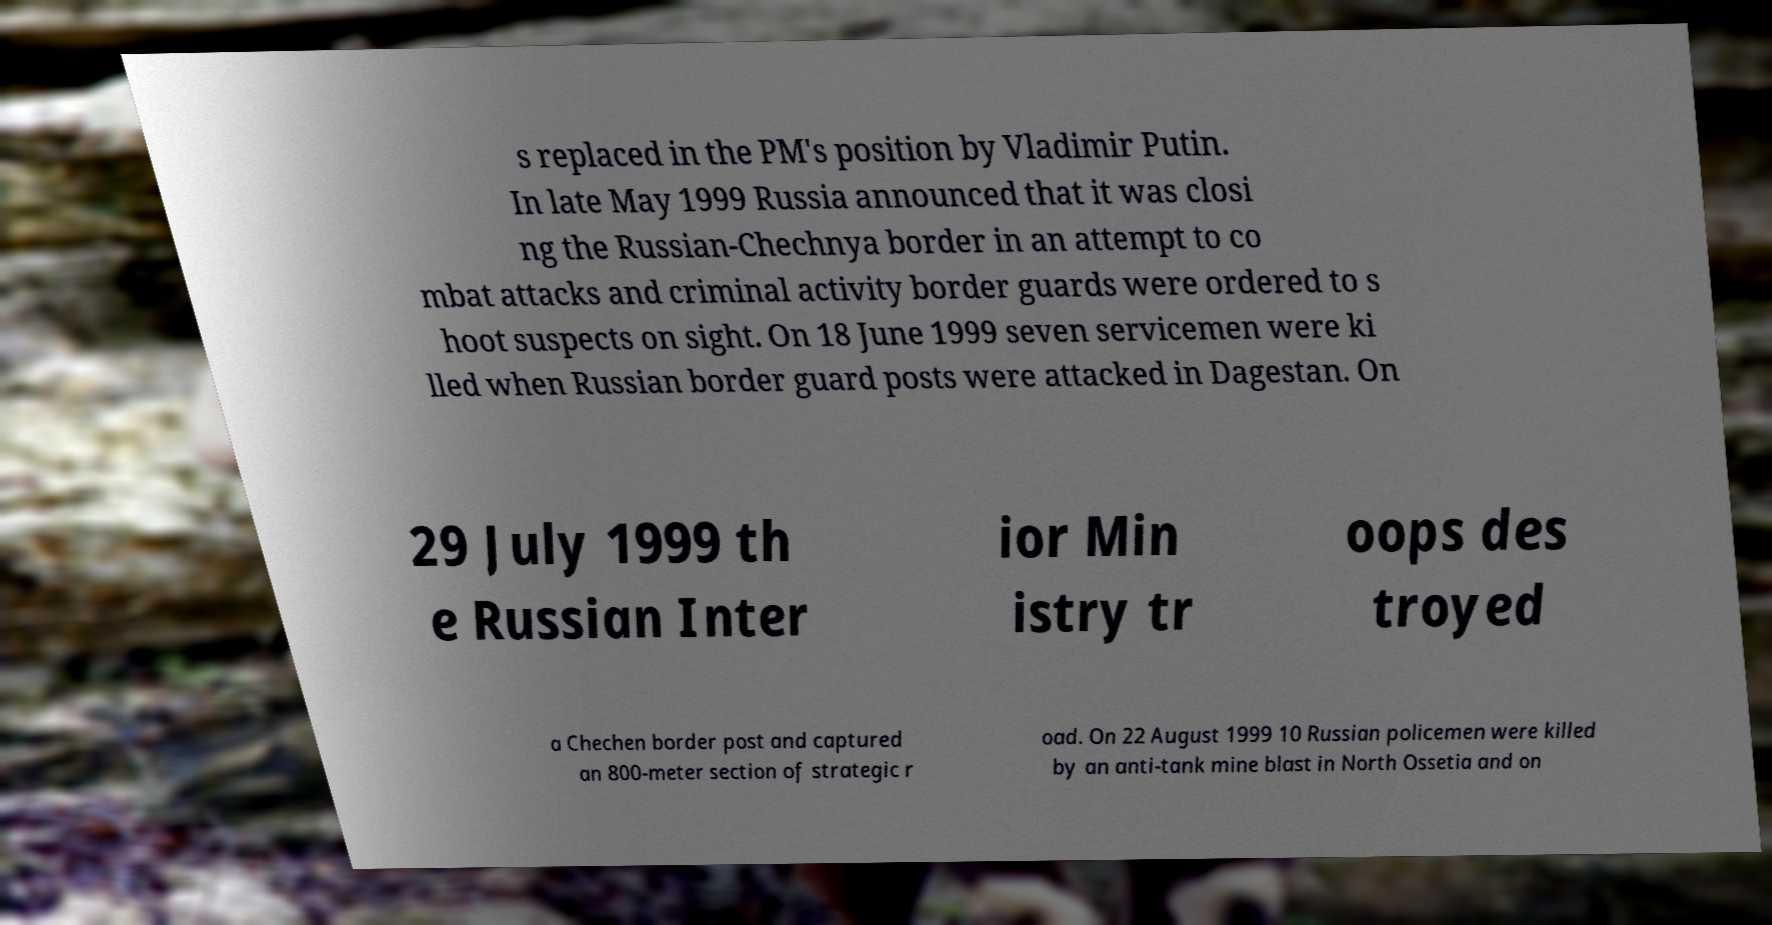Could you extract and type out the text from this image? s replaced in the PM's position by Vladimir Putin. In late May 1999 Russia announced that it was closi ng the Russian-Chechnya border in an attempt to co mbat attacks and criminal activity border guards were ordered to s hoot suspects on sight. On 18 June 1999 seven servicemen were ki lled when Russian border guard posts were attacked in Dagestan. On 29 July 1999 th e Russian Inter ior Min istry tr oops des troyed a Chechen border post and captured an 800-meter section of strategic r oad. On 22 August 1999 10 Russian policemen were killed by an anti-tank mine blast in North Ossetia and on 